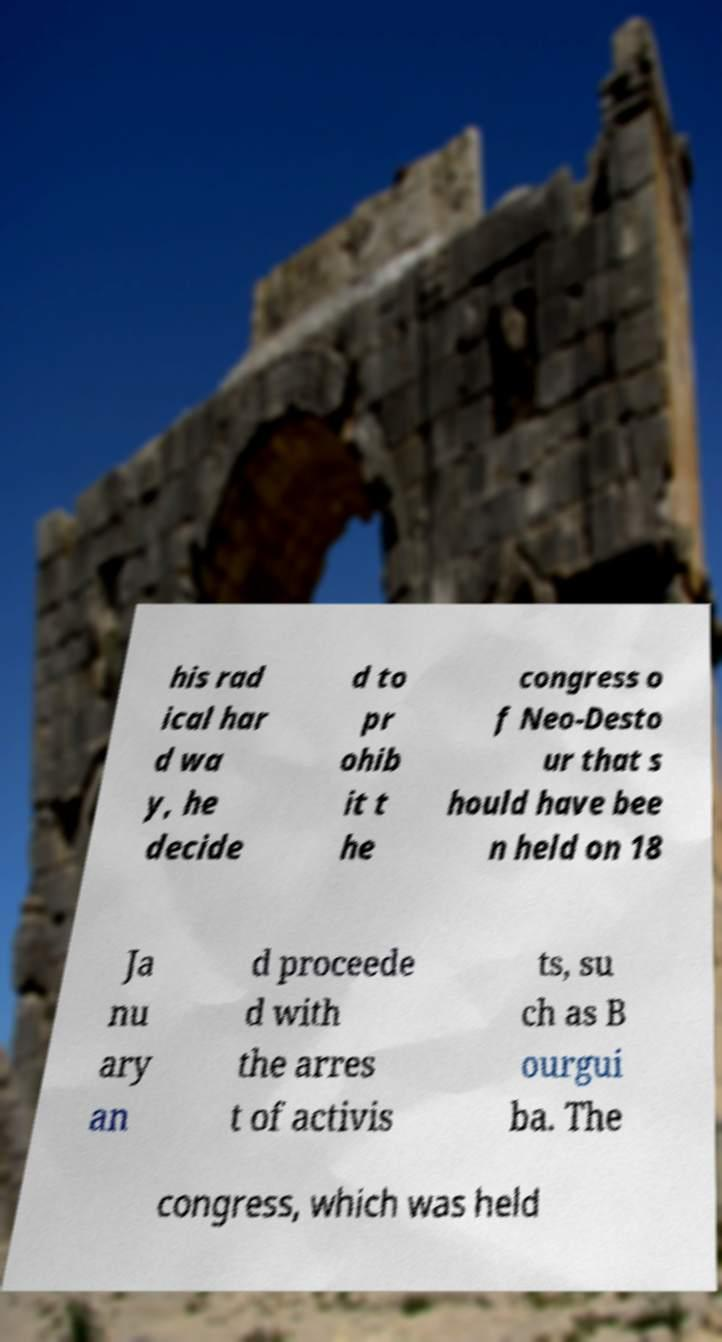Can you accurately transcribe the text from the provided image for me? his rad ical har d wa y, he decide d to pr ohib it t he congress o f Neo-Desto ur that s hould have bee n held on 18 Ja nu ary an d proceede d with the arres t of activis ts, su ch as B ourgui ba. The congress, which was held 